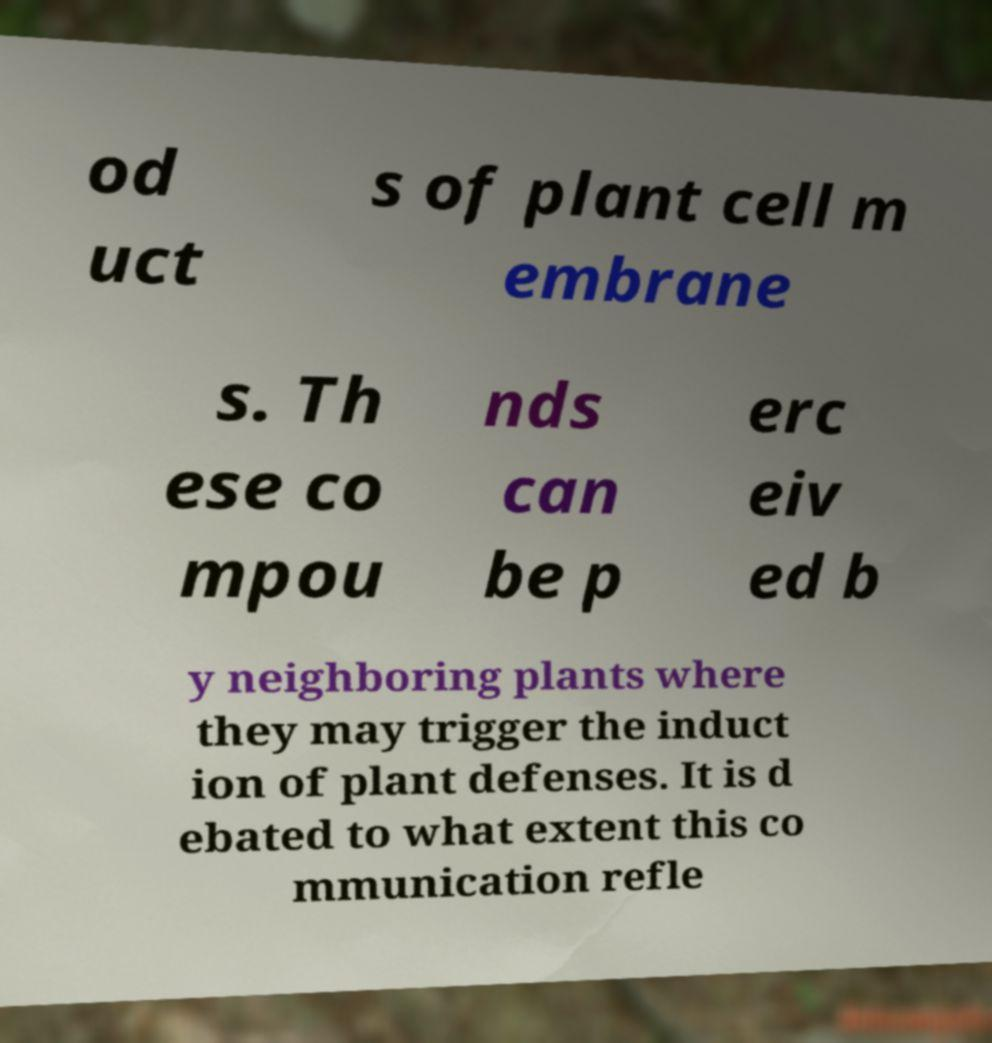Could you assist in decoding the text presented in this image and type it out clearly? od uct s of plant cell m embrane s. Th ese co mpou nds can be p erc eiv ed b y neighboring plants where they may trigger the induct ion of plant defenses. It is d ebated to what extent this co mmunication refle 